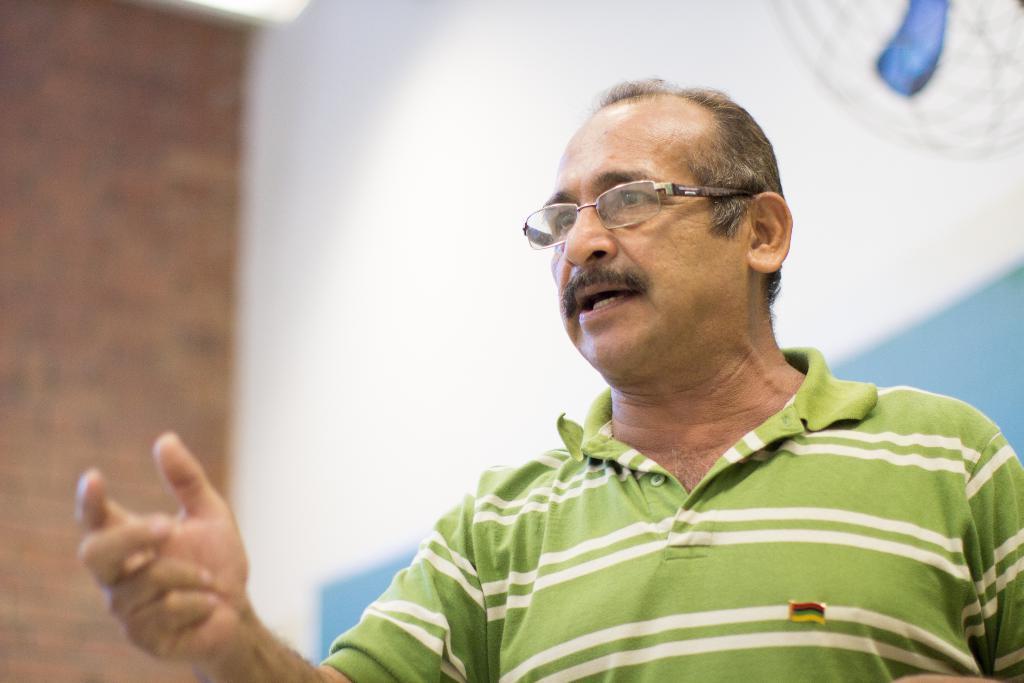Please provide a concise description of this image. In the center of the image there is a person. In the background of the image there is wall. 